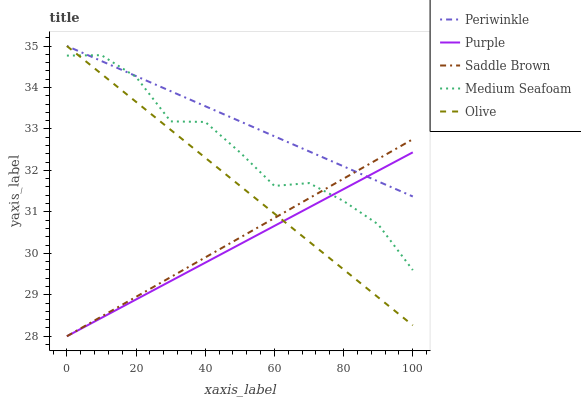Does Olive have the minimum area under the curve?
Answer yes or no. No. Does Olive have the maximum area under the curve?
Answer yes or no. No. Is Olive the smoothest?
Answer yes or no. No. Is Olive the roughest?
Answer yes or no. No. Does Olive have the lowest value?
Answer yes or no. No. Does Saddle Brown have the highest value?
Answer yes or no. No. 